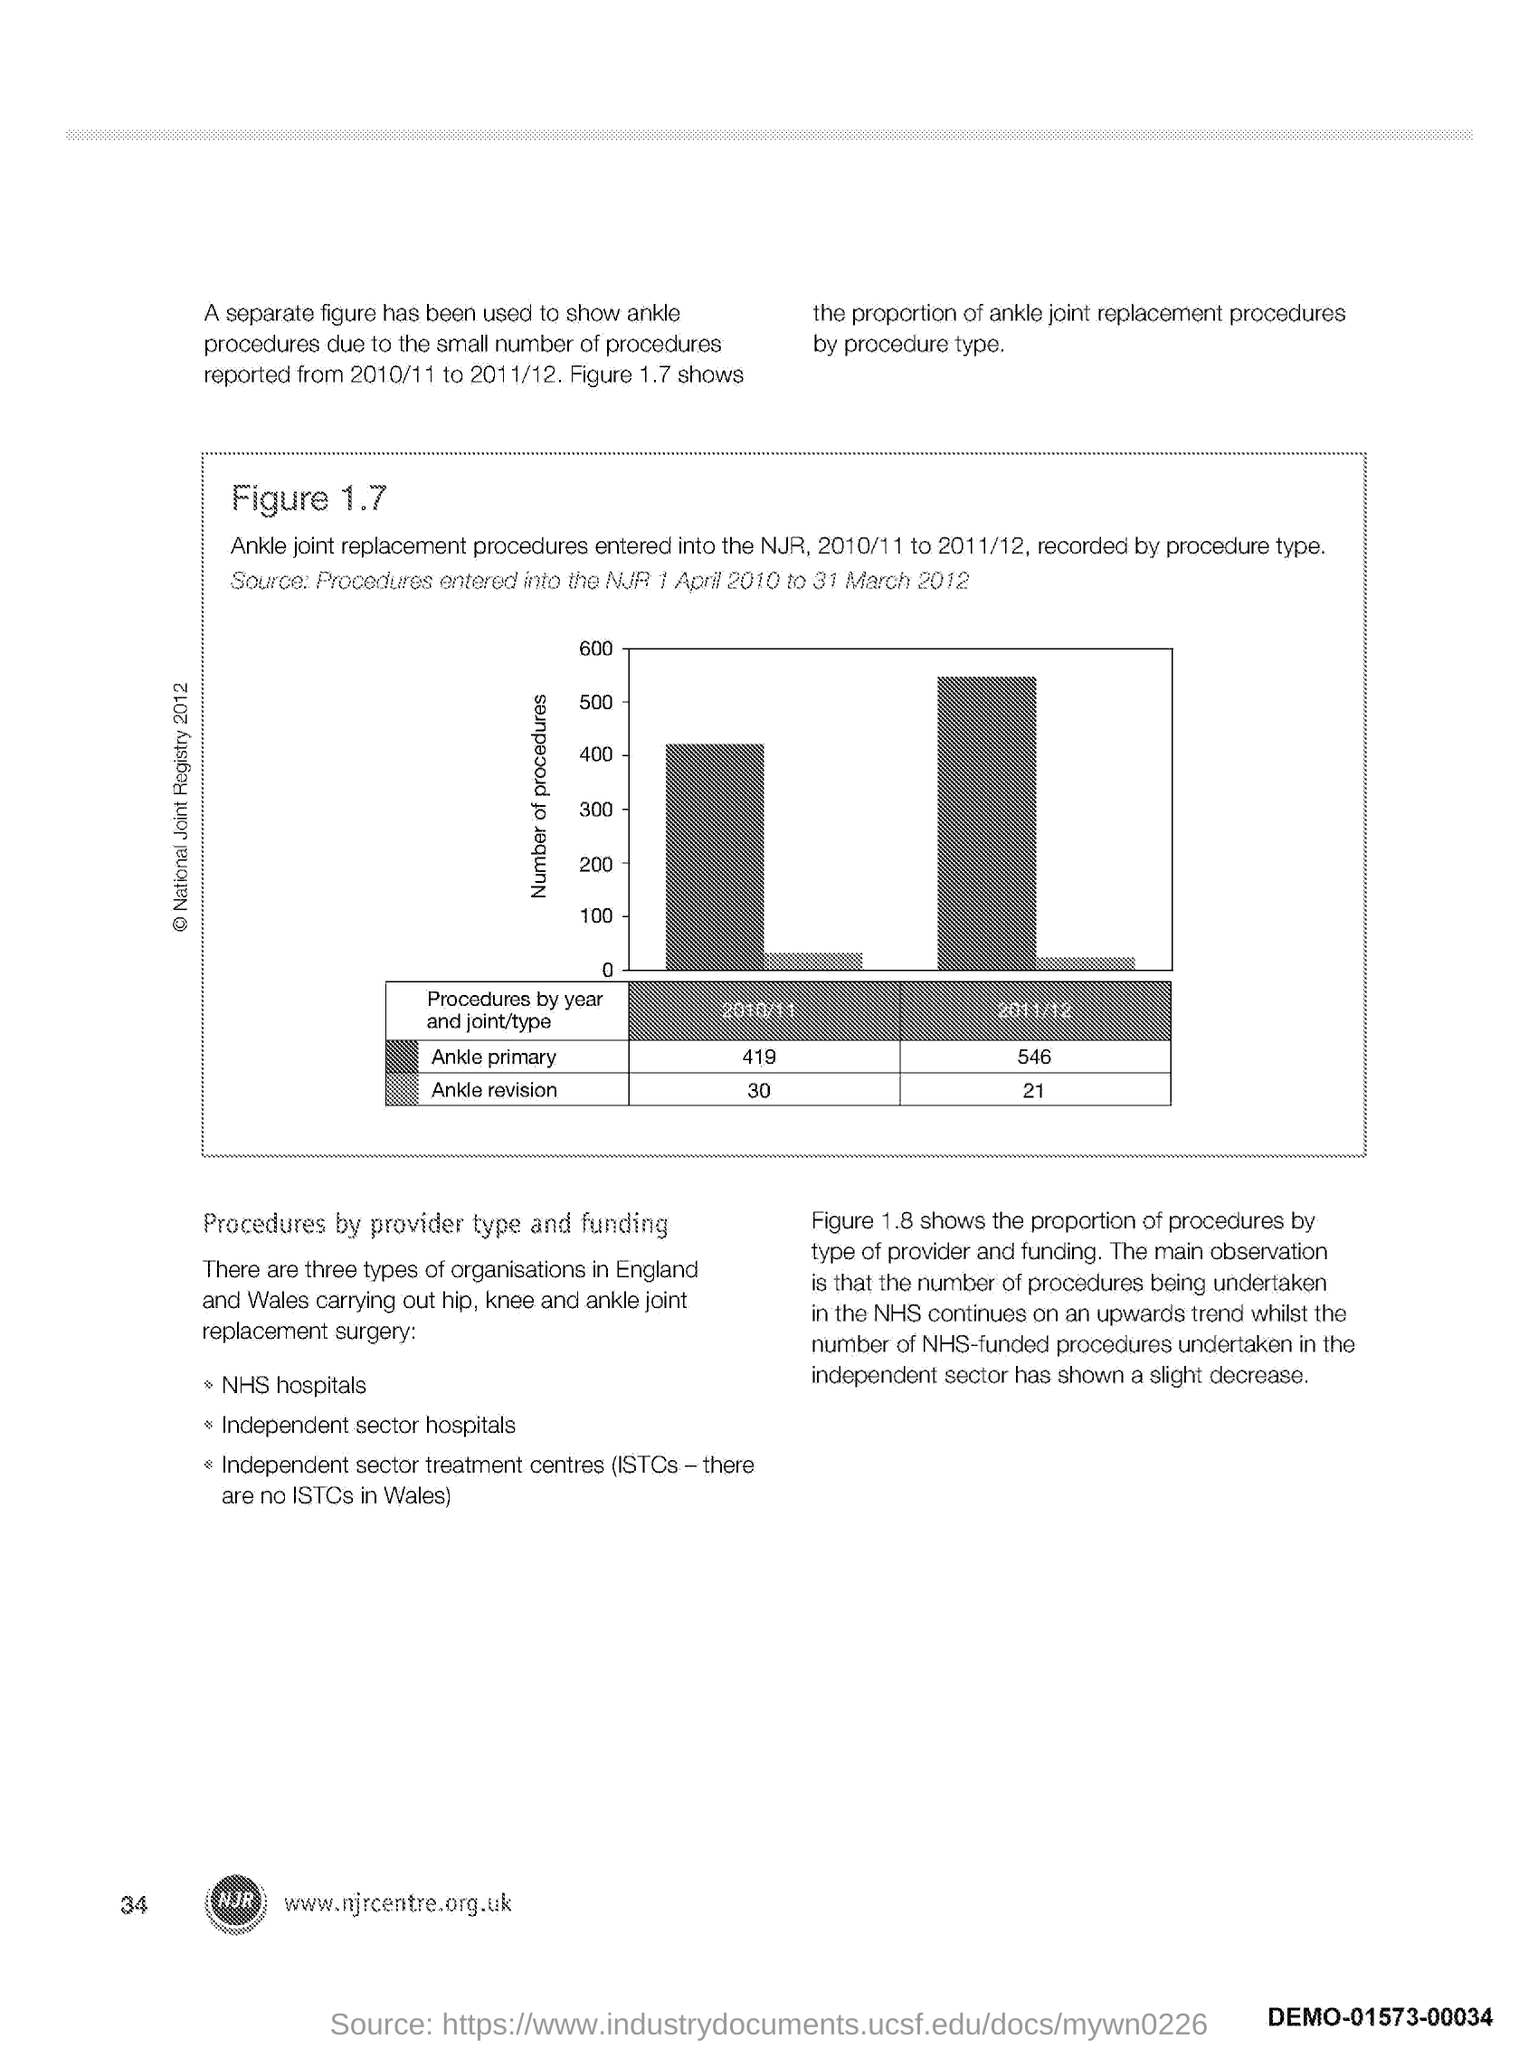List a handful of essential elements in this visual. The y-axis represents the number of procedures performed. The page number is 34. 